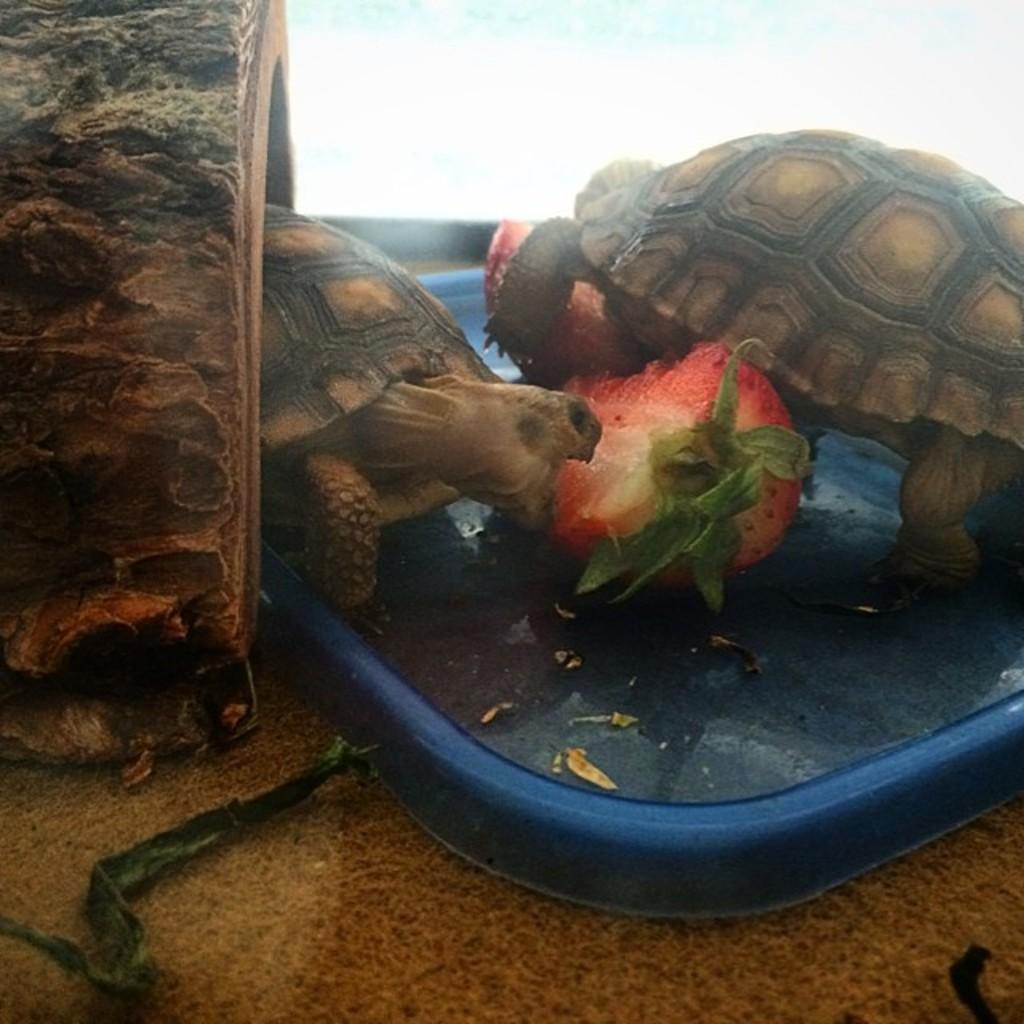Describe this image in one or two sentences. In this picture we can see there are two tortoises on a blue object and in between the tortoises there is a fruit. On the left side of the tortoises there is a wooden item. 